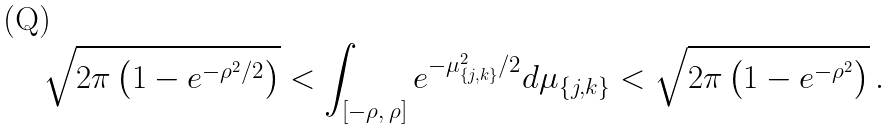<formula> <loc_0><loc_0><loc_500><loc_500>\sqrt { 2 \pi \left ( 1 - e ^ { - \rho ^ { 2 } / 2 } \right ) } < \int _ { [ - \rho , \, \rho ] } e ^ { - \mu _ { \{ j , k \} } ^ { 2 } / 2 } d \mu _ { \{ j , k \} } < \sqrt { 2 \pi \left ( 1 - e ^ { - \rho ^ { 2 } } \right ) } \, .</formula> 